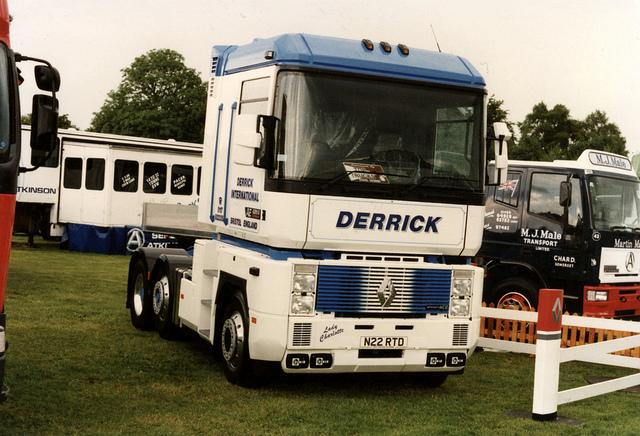Is the truck rusted?
Be succinct. No. What is written on the front of the pickup truck?
Concise answer only. Derrick. What is the truck driving on?
Write a very short answer. Grass. What brand of truck is this?
Keep it brief. Derrick. What company built the trucks?
Give a very brief answer. Derrick. Is this the latest make and model?
Short answer required. No. Are the first and second trucks of similar size and shape?
Write a very short answer. Yes. Is this truck parked?
Short answer required. Yes. What is the band logo name for this vehicle?
Give a very brief answer. Derrick. Who made the truck on the right?
Give a very brief answer. Derrick. What do the white letters above the windshield say?
Answer briefly. Derrick. What color is the truck?
Concise answer only. White. Is the truck on a country field?
Quick response, please. Yes. What company are these trucks from?
Give a very brief answer. Derrick. What is the ground made of?
Write a very short answer. Grass. What color is the fence?
Be succinct. White. What are the orange things next to the RV?
Give a very brief answer. Fence. 